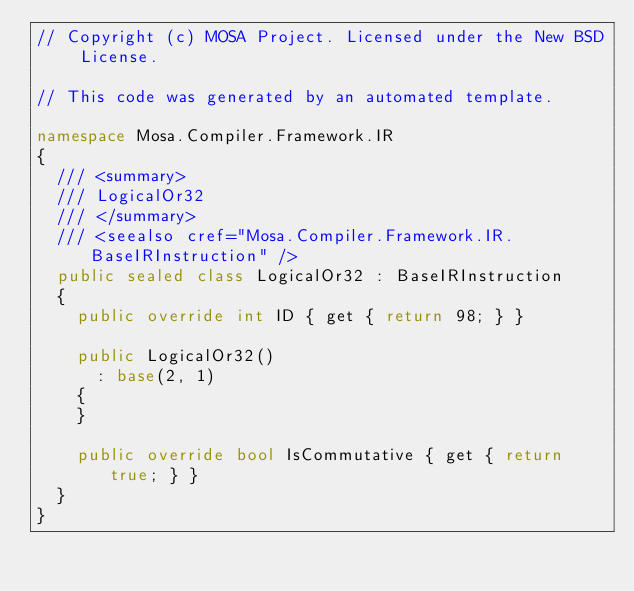<code> <loc_0><loc_0><loc_500><loc_500><_C#_>// Copyright (c) MOSA Project. Licensed under the New BSD License.

// This code was generated by an automated template.

namespace Mosa.Compiler.Framework.IR
{
	/// <summary>
	/// LogicalOr32
	/// </summary>
	/// <seealso cref="Mosa.Compiler.Framework.IR.BaseIRInstruction" />
	public sealed class LogicalOr32 : BaseIRInstruction
	{
		public override int ID { get { return 98; } }

		public LogicalOr32()
			: base(2, 1)
		{
		}

		public override bool IsCommutative { get { return true; } }
	}
}
</code> 